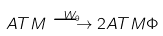<formula> <loc_0><loc_0><loc_500><loc_500>A T M \overset { W _ { 9 } } { \longrightarrow } 2 A T M \Phi</formula> 